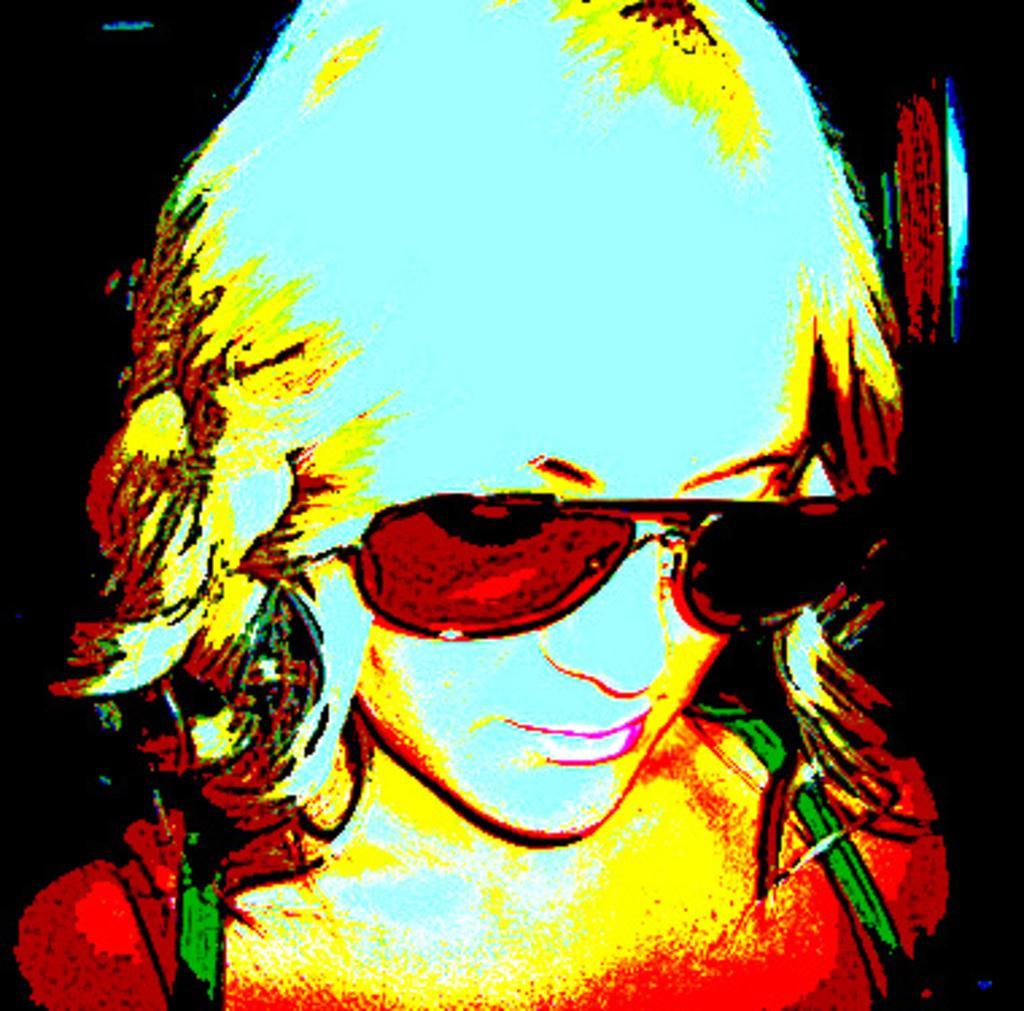Can you describe this image briefly? This is an edited image of a woman. 